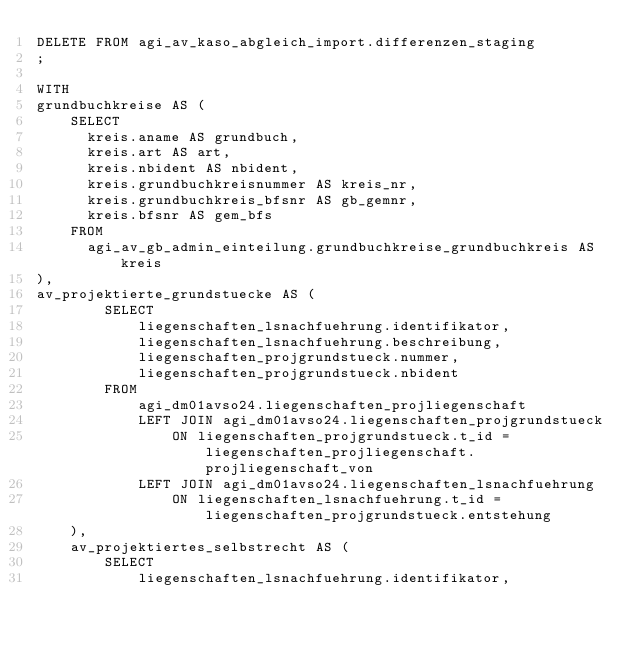<code> <loc_0><loc_0><loc_500><loc_500><_SQL_>DELETE FROM agi_av_kaso_abgleich_import.differenzen_staging
;

WITH 
grundbuchkreise AS (
    SELECT
      kreis.aname AS grundbuch,
      kreis.art AS art,
      kreis.nbident AS nbident,
      kreis.grundbuchkreisnummer AS kreis_nr,
      kreis.grundbuchkreis_bfsnr AS gb_gemnr,
      kreis.bfsnr AS gem_bfs
    FROM
      agi_av_gb_admin_einteilung.grundbuchkreise_grundbuchkreis AS kreis  
),
av_projektierte_grundstuecke AS (
        SELECT
            liegenschaften_lsnachfuehrung.identifikator,
            liegenschaften_lsnachfuehrung.beschreibung,
            liegenschaften_projgrundstueck.nummer,
            liegenschaften_projgrundstueck.nbident
        FROM
            agi_dm01avso24.liegenschaften_projliegenschaft
            LEFT JOIN agi_dm01avso24.liegenschaften_projgrundstueck
                ON liegenschaften_projgrundstueck.t_id = liegenschaften_projliegenschaft.projliegenschaft_von
            LEFT JOIN agi_dm01avso24.liegenschaften_lsnachfuehrung
                ON liegenschaften_lsnachfuehrung.t_id = liegenschaften_projgrundstueck.entstehung
    ),
    av_projektiertes_selbstrecht AS (
        SELECT
            liegenschaften_lsnachfuehrung.identifikator,</code> 